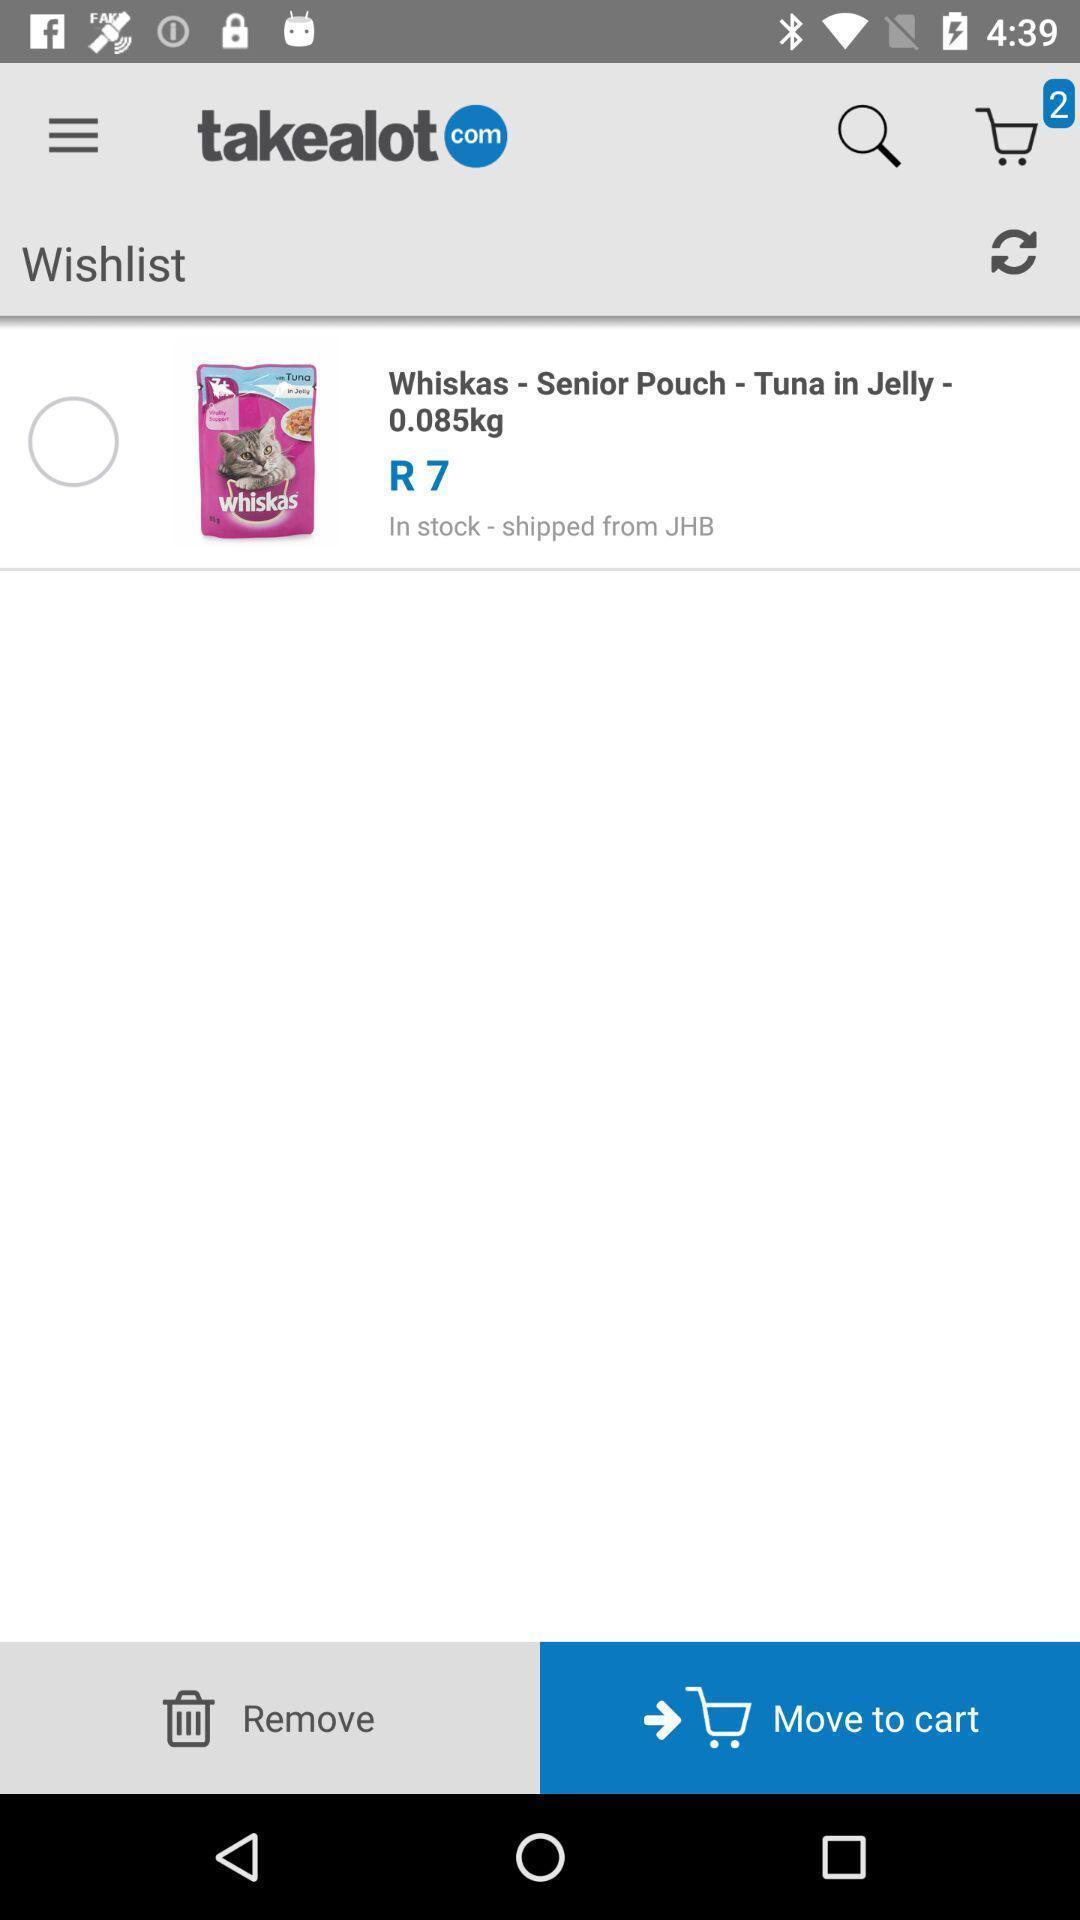Summarize the main components in this picture. Screen page of a shopping app. 